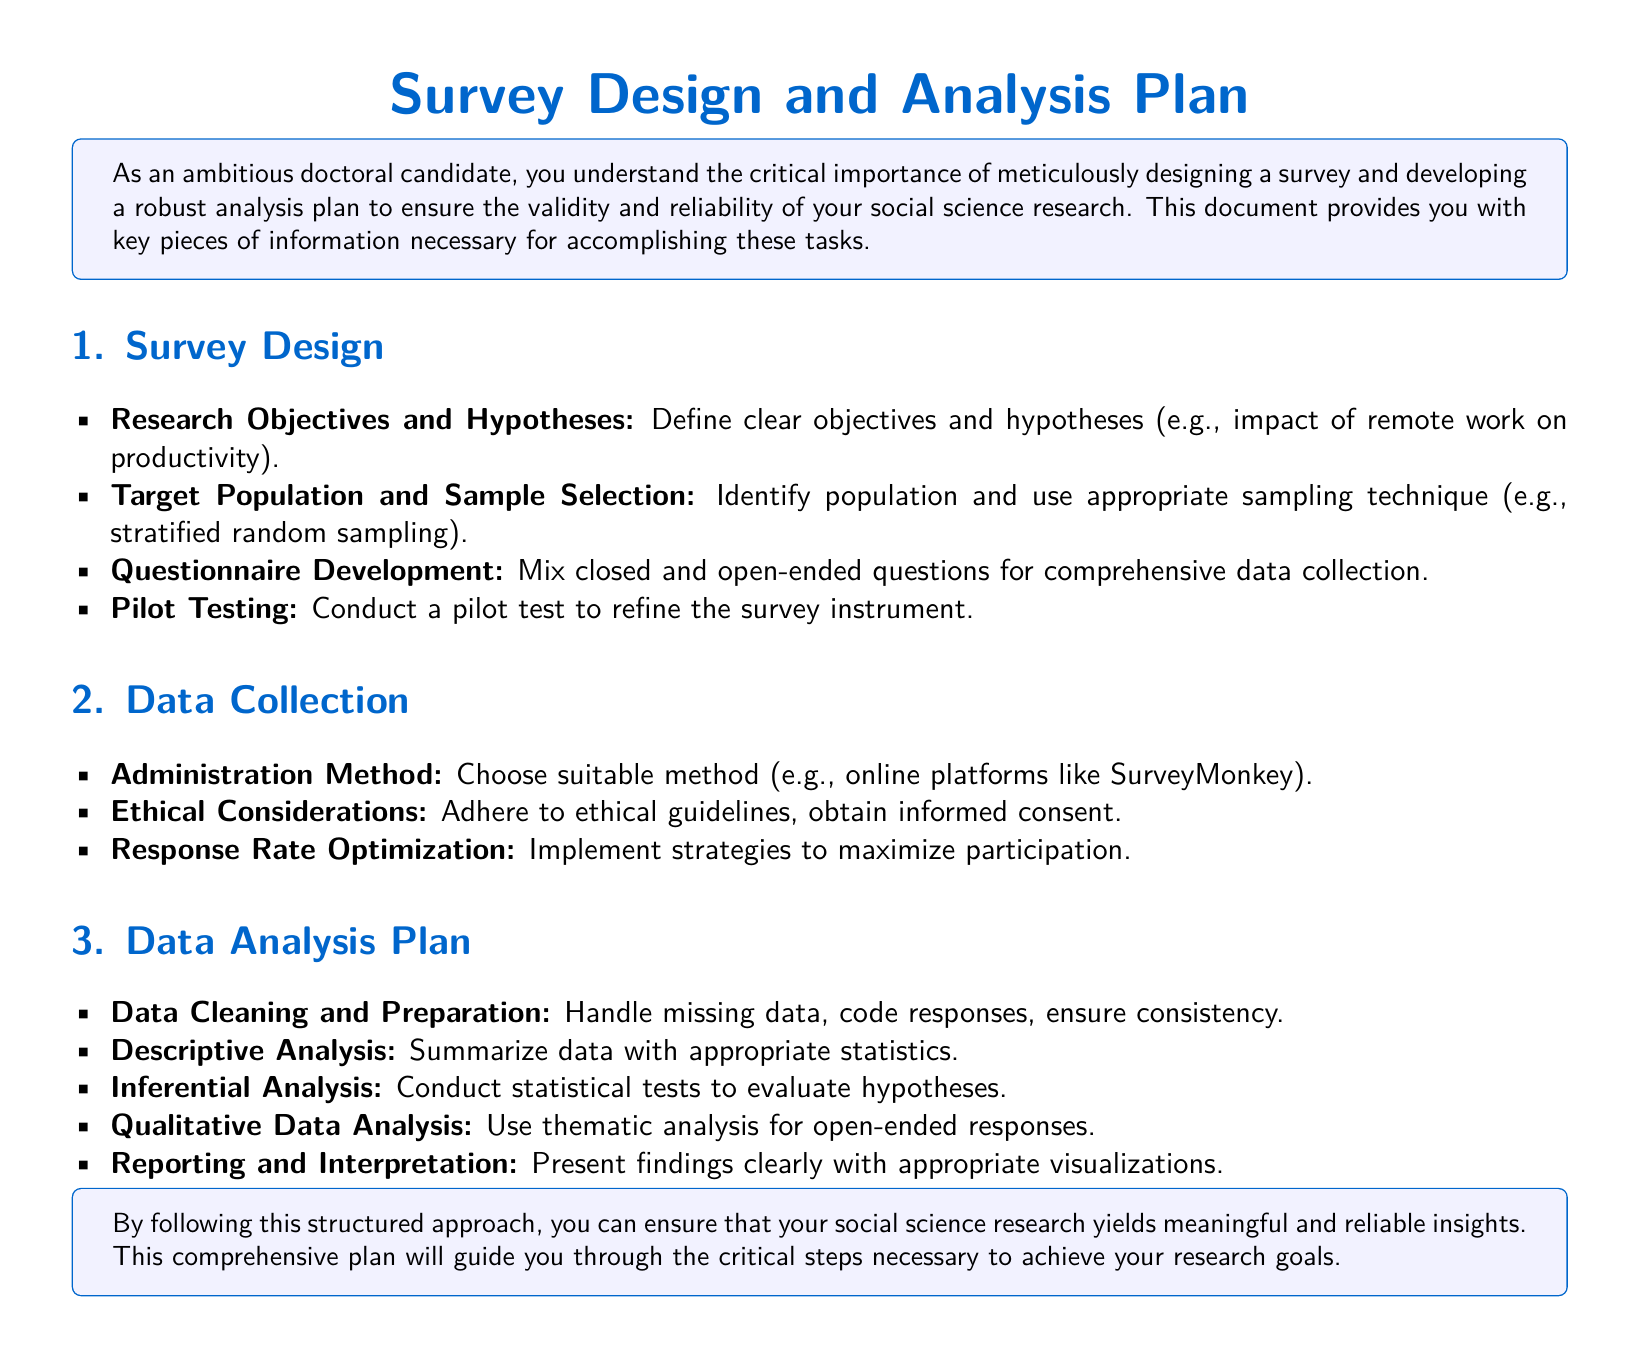What is the title of the document? The title of the document is the main heading presented prominently at the top.
Answer: Survey Design and Analysis Plan What is the primary focus of the research objectives? The primary focus is indicated in the example provided within the document.
Answer: Impact of remote work on productivity What sampling technique is suggested? The document mentions a specific method for selecting samples.
Answer: Stratified random sampling Which method is recommended for survey administration? The document specifies a type of platform suitable for conducting surveys.
Answer: Online platforms like SurveyMonkey What type of analysis is used for open-ended responses? The document outlines a particular approach for qualitative data derived from open-ended questions.
Answer: Thematic analysis What is the first step in the data analysis plan? The document lists essential steps in the analysis plan, starting with a particular action.
Answer: Data cleaning and preparation What is essential for maximizing response rates? The document suggests implementing specific strategies to encourage participation.
Answer: Strategies to maximize participation What ethical practice must be followed according to the document? The document emphasizes a critical aspect of conducting research in an ethical manner.
Answer: Obtain informed consent What visual aid is suggested for reporting findings? The document indicates a method to present the research outcomes effectively.
Answer: Appropriate visualizations 